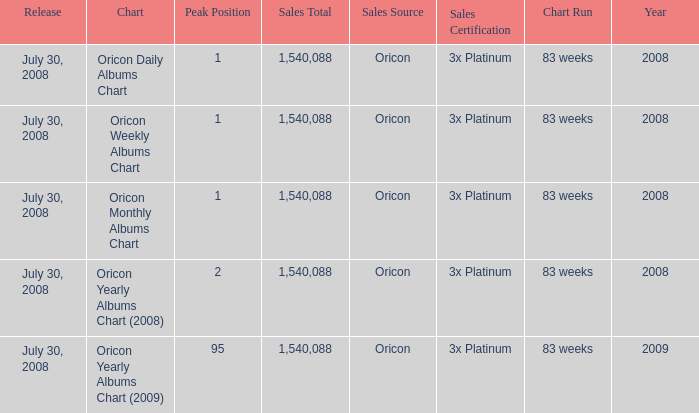Which Sales Total has a Chart of oricon monthly albums chart? 1540088.0. 